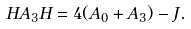Convert formula to latex. <formula><loc_0><loc_0><loc_500><loc_500>H A _ { 3 } H = 4 ( A _ { 0 } + A _ { 3 } ) - J .</formula> 